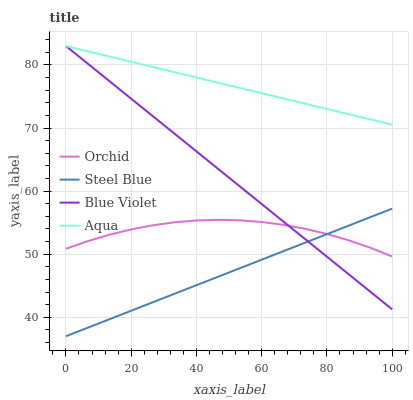Does Steel Blue have the minimum area under the curve?
Answer yes or no. Yes. Does Aqua have the maximum area under the curve?
Answer yes or no. Yes. Does Blue Violet have the minimum area under the curve?
Answer yes or no. No. Does Blue Violet have the maximum area under the curve?
Answer yes or no. No. Is Blue Violet the smoothest?
Answer yes or no. Yes. Is Orchid the roughest?
Answer yes or no. Yes. Is Steel Blue the smoothest?
Answer yes or no. No. Is Steel Blue the roughest?
Answer yes or no. No. Does Steel Blue have the lowest value?
Answer yes or no. Yes. Does Blue Violet have the lowest value?
Answer yes or no. No. Does Blue Violet have the highest value?
Answer yes or no. Yes. Does Steel Blue have the highest value?
Answer yes or no. No. Is Orchid less than Aqua?
Answer yes or no. Yes. Is Aqua greater than Orchid?
Answer yes or no. Yes. Does Steel Blue intersect Orchid?
Answer yes or no. Yes. Is Steel Blue less than Orchid?
Answer yes or no. No. Is Steel Blue greater than Orchid?
Answer yes or no. No. Does Orchid intersect Aqua?
Answer yes or no. No. 